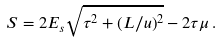<formula> <loc_0><loc_0><loc_500><loc_500>S = 2 E _ { s } \sqrt { \tau ^ { 2 } + ( L / u ) ^ { 2 } } - 2 \tau \mu \, .</formula> 